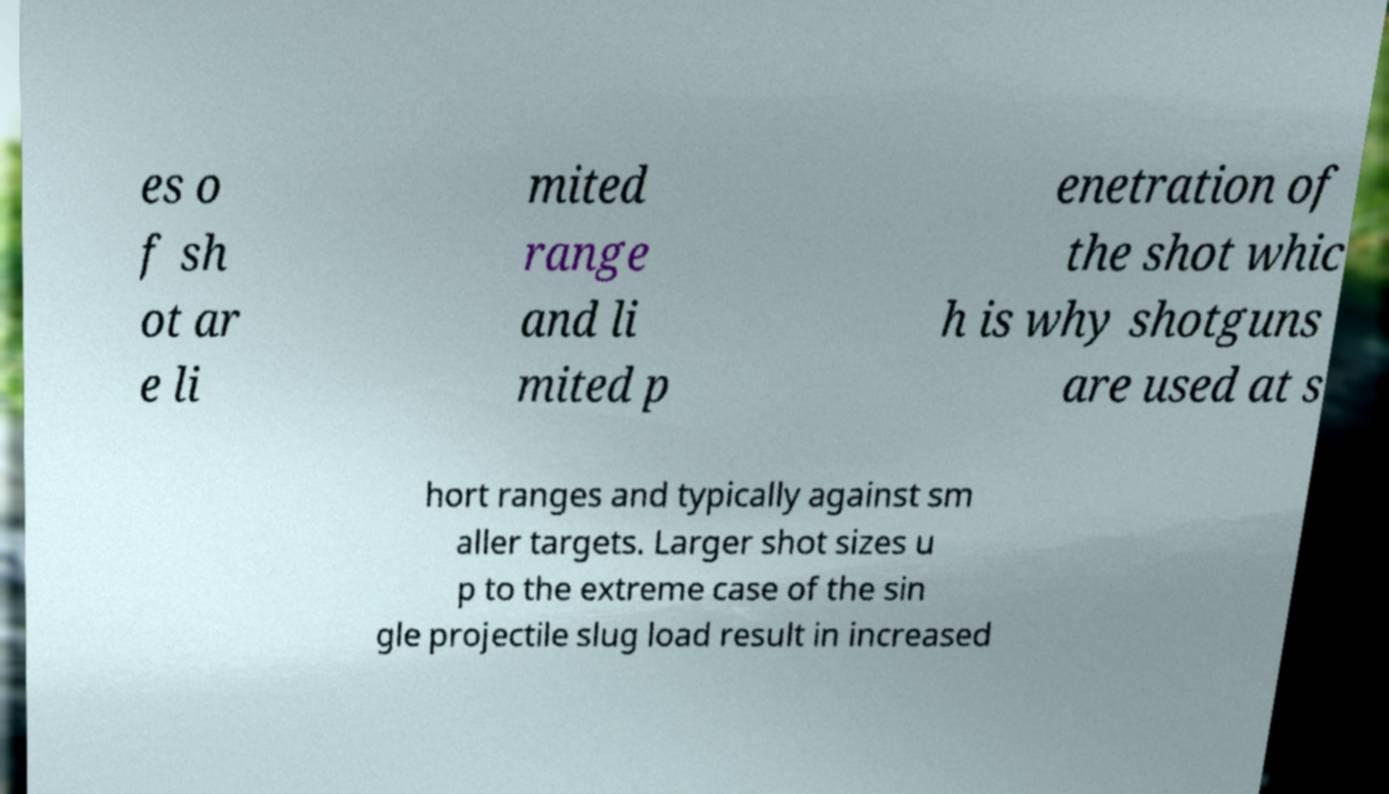Please identify and transcribe the text found in this image. es o f sh ot ar e li mited range and li mited p enetration of the shot whic h is why shotguns are used at s hort ranges and typically against sm aller targets. Larger shot sizes u p to the extreme case of the sin gle projectile slug load result in increased 